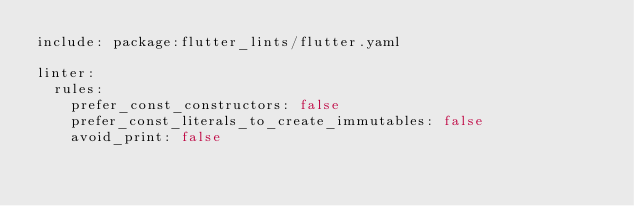Convert code to text. <code><loc_0><loc_0><loc_500><loc_500><_YAML_>include: package:flutter_lints/flutter.yaml

linter:
  rules:
    prefer_const_constructors: false
    prefer_const_literals_to_create_immutables: false
    avoid_print: false</code> 